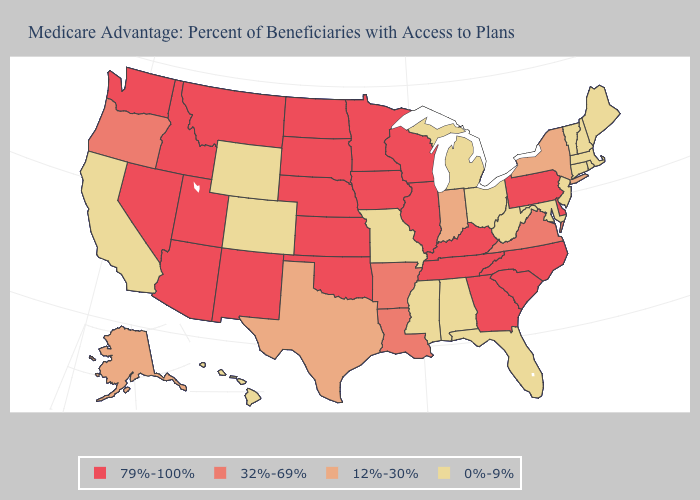What is the highest value in the USA?
Be succinct. 79%-100%. Does the map have missing data?
Keep it brief. No. What is the value of Wisconsin?
Concise answer only. 79%-100%. Does the map have missing data?
Keep it brief. No. What is the value of Tennessee?
Keep it brief. 79%-100%. Name the states that have a value in the range 12%-30%?
Keep it brief. Alaska, Indiana, New York, Texas. Name the states that have a value in the range 0%-9%?
Quick response, please. Alabama, California, Colorado, Connecticut, Florida, Hawaii, Massachusetts, Maryland, Maine, Michigan, Missouri, Mississippi, New Hampshire, New Jersey, Ohio, Rhode Island, Vermont, West Virginia, Wyoming. What is the highest value in states that border Tennessee?
Quick response, please. 79%-100%. Does Colorado have the lowest value in the USA?
Write a very short answer. Yes. Which states hav the highest value in the West?
Keep it brief. Arizona, Idaho, Montana, New Mexico, Nevada, Utah, Washington. What is the lowest value in the South?
Quick response, please. 0%-9%. Does New Hampshire have the lowest value in the USA?
Keep it brief. Yes. What is the highest value in the USA?
Keep it brief. 79%-100%. What is the value of West Virginia?
Write a very short answer. 0%-9%. Name the states that have a value in the range 0%-9%?
Quick response, please. Alabama, California, Colorado, Connecticut, Florida, Hawaii, Massachusetts, Maryland, Maine, Michigan, Missouri, Mississippi, New Hampshire, New Jersey, Ohio, Rhode Island, Vermont, West Virginia, Wyoming. 